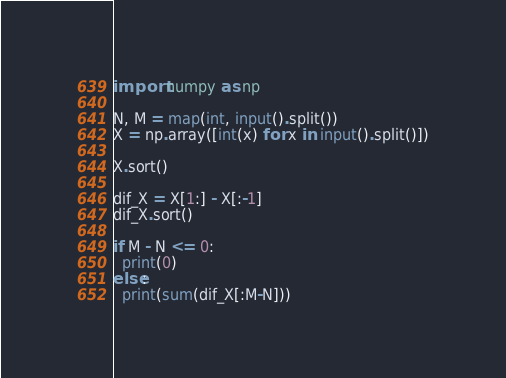<code> <loc_0><loc_0><loc_500><loc_500><_Python_>import numpy as np

N, M = map(int, input().split())
X = np.array([int(x) for x in input().split()])

X.sort()

dif_X = X[1:] - X[:-1]
dif_X.sort()

if M - N <= 0:
  print(0)
else:
  print(sum(dif_X[:M-N]))</code> 